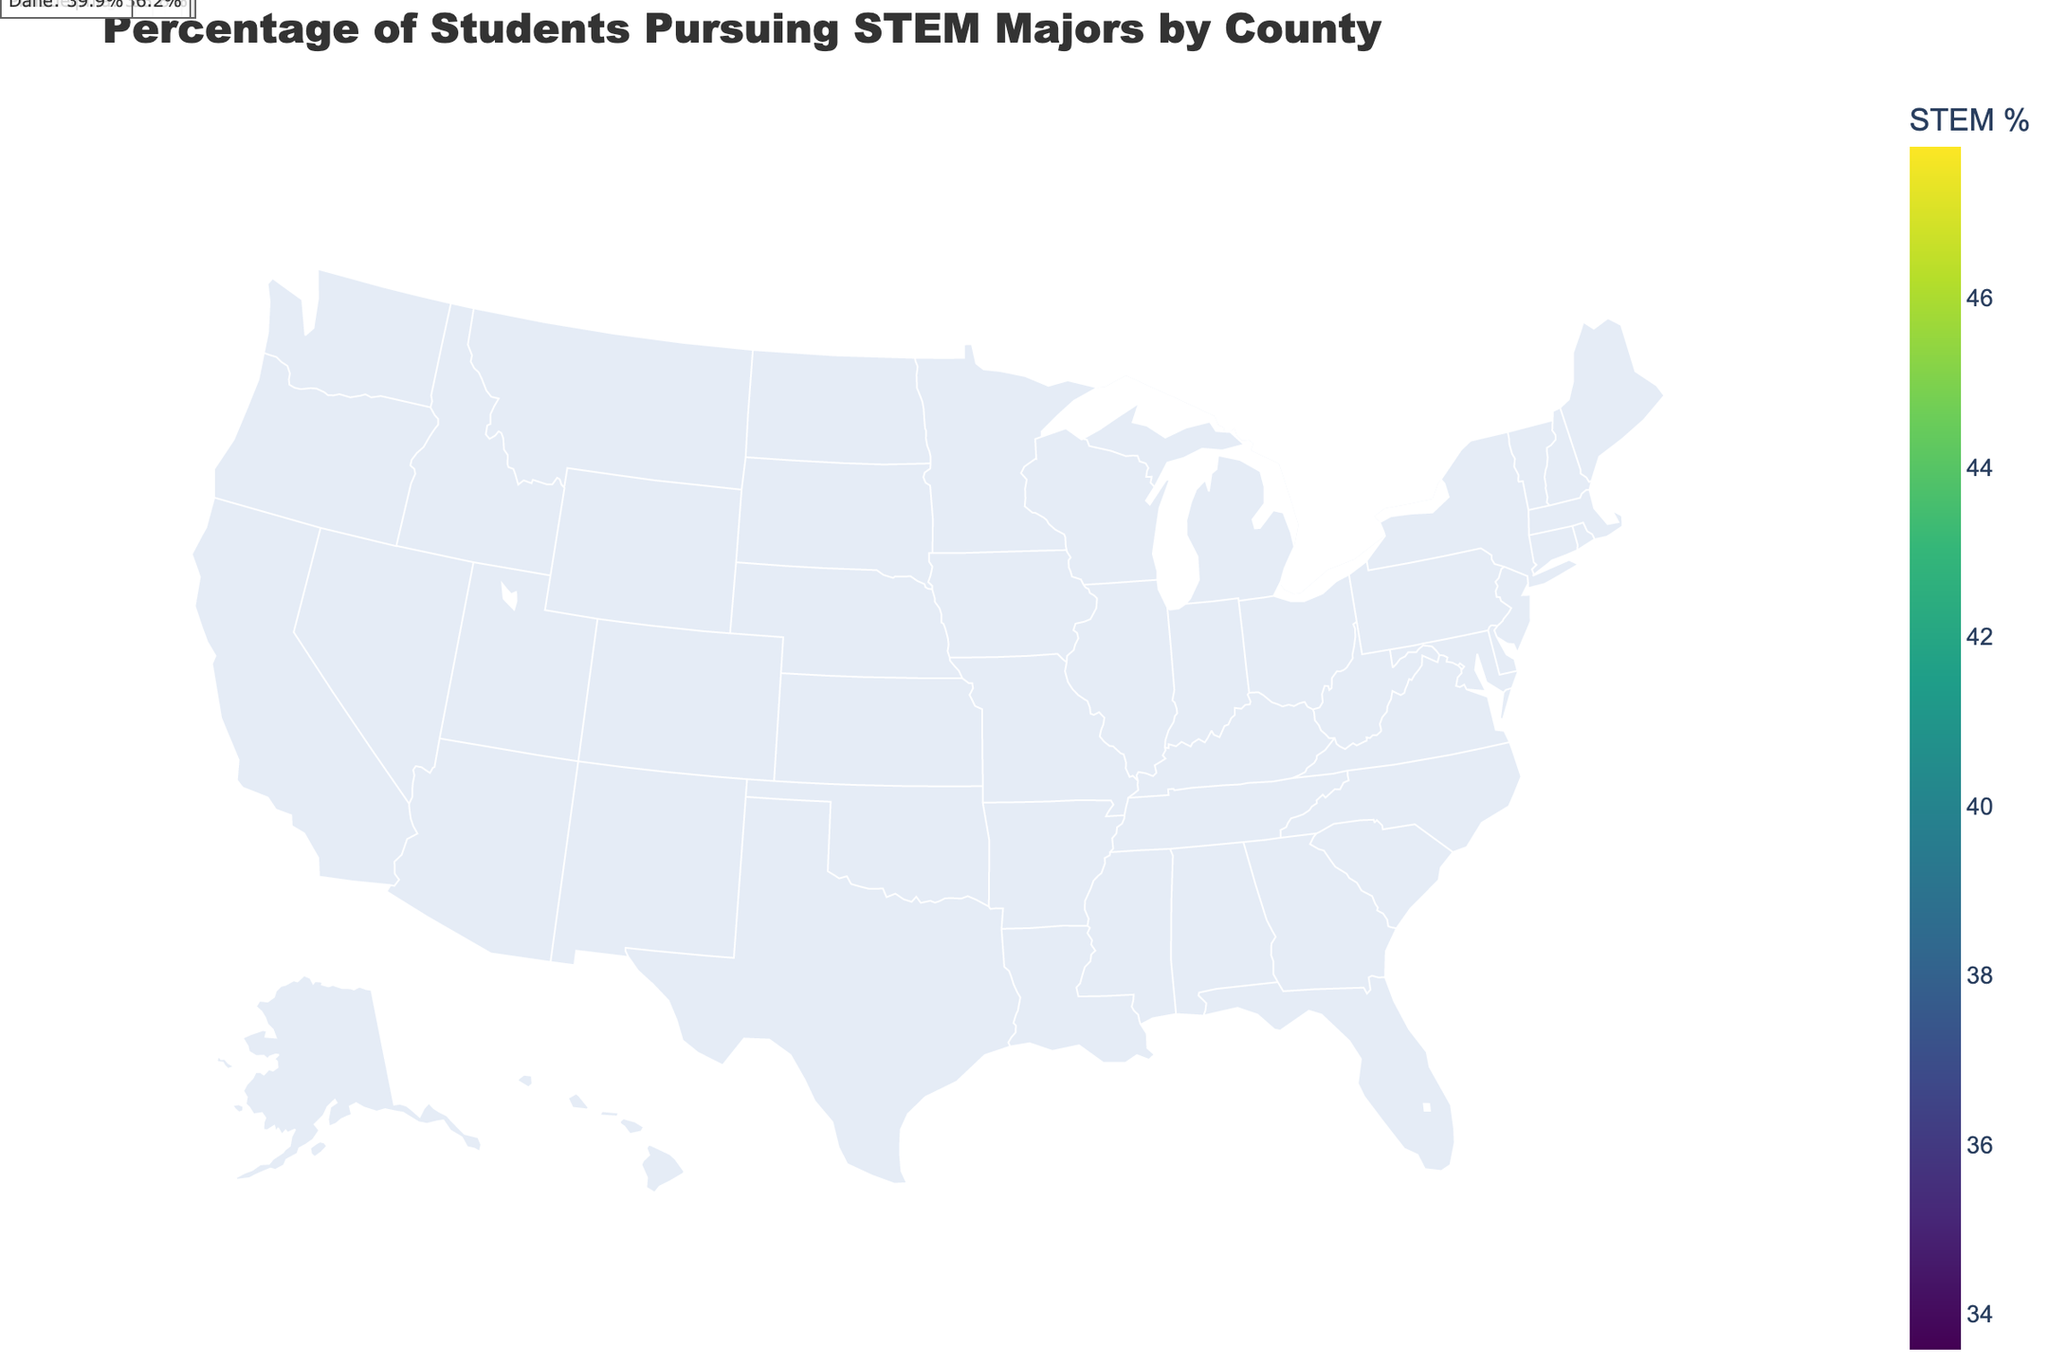What is the title of the figure? The title is usually found at the top of the figure in larger or bold font. In this case, it reads "Percentage of Students Pursuing STEM Majors by County".
Answer: Percentage of Students Pursuing STEM Majors by County Which county in California has the highest percentage of students pursuing STEM majors? By looking at the counties in California and their corresponding percentages, we can see that Santa Clara has the highest percentage at 47.8%.
Answer: Santa Clara What is the color range indicating in the plot? The color range on the plot is a continuous scale representing the percentage of students pursuing STEM majors. Each color corresponds to a different percentage value.
Answer: Percentage of students pursuing STEM What is the percentage of students pursuing STEM majors in Middlesex County, Massachusetts? Locate Middlesex County in Massachusetts on the plot and check the labeled percentage. It shows 45.2%.
Answer: 45.2% How many counties on the map have a percentage above 40%? Identify the counties with percentages above 40%: San Mateo (42.3%), King (41.5%), Middlesex (45.2%), Santa Clara (47.8%), Alameda (43.6%), Montgomery (40.7%), Fairfax (42.9%), Boulder (44.1%), and Dane (39.9%). Total is 8.
Answer: 8 Compare the percentage of students pursuing STEM majors between Wake County, North Carolina and Hennepin County, Minnesota. Which one has a higher percentage? Locate both counties on the plot. Wake County has 39.4% while Hennepin County has 37.1%. Wake County has a higher percentage.
Answer: Wake County What is the average percentage of students pursuing STEM majors in all counties presented in the figure? Sum all the percentages and divide by the number of counties. (42.3 + 38.7 + 41.5 + 45.2 + 47.8 + 36.9 + 39.4 + 37.1 + 43.6 + 34.8 + 40.7 + 35.3 + 42.9 + 33.6 + 38.2 + 37.5 + 44.1 + 35.8 + 36.2 + 39.9) / 20 = 39.73.
Answer: 39.73% Which state has more counties listed in the plot, Texas or California? Count the number of counties from each state in the data provided. California has San Mateo, Santa Clara, and Alameda (3 counties). Texas has Travis and Harris (2 counties).
Answer: California What is the percentage difference of students pursuing STEM majors between the counties with the highest and lowest percentages? Identify the highest (Santa Clara, 47.8%) and lowest (Multnomah, 33.6%) percentages, then subtract the lowest from the highest: 47.8% - 33.6% = 14.2%.
Answer: 14.2% Which county has the lowest percentage of students pursuing STEM majors and what is that percentage? Locate the county with the lowest percentage on the plot or in the data table. Multnomah County, Oregon has the lowest percentage at 33.6%.
Answer: Multnomah County, 33.6% 